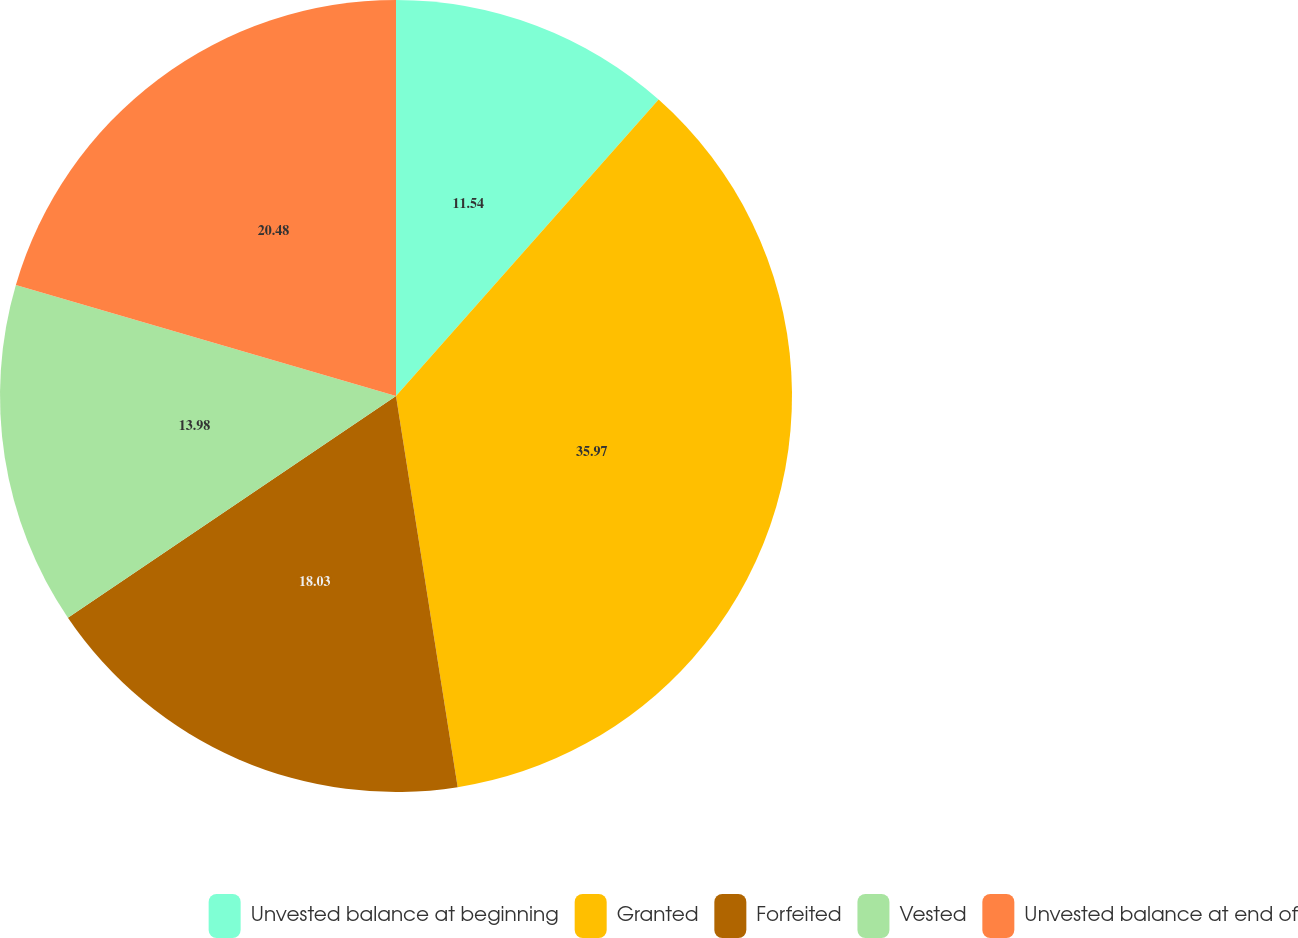Convert chart to OTSL. <chart><loc_0><loc_0><loc_500><loc_500><pie_chart><fcel>Unvested balance at beginning<fcel>Granted<fcel>Forfeited<fcel>Vested<fcel>Unvested balance at end of<nl><fcel>11.54%<fcel>35.97%<fcel>18.03%<fcel>13.98%<fcel>20.48%<nl></chart> 